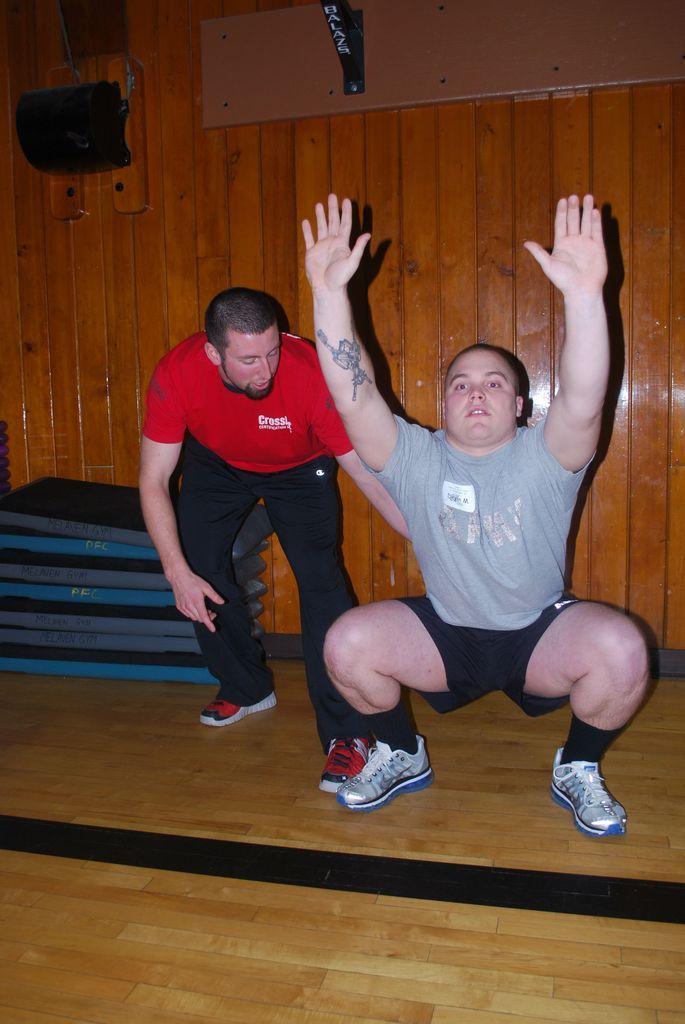In one or two sentences, can you explain what this image depicts? In this picture there is a man who is squat position. He is wearing t-shirt, short and shoe, beside him there is another person who is wearing red t-shirt, black trouser and shoe, beside him i can see many mattress. In the top left corner i can see the speakers on the wall. 